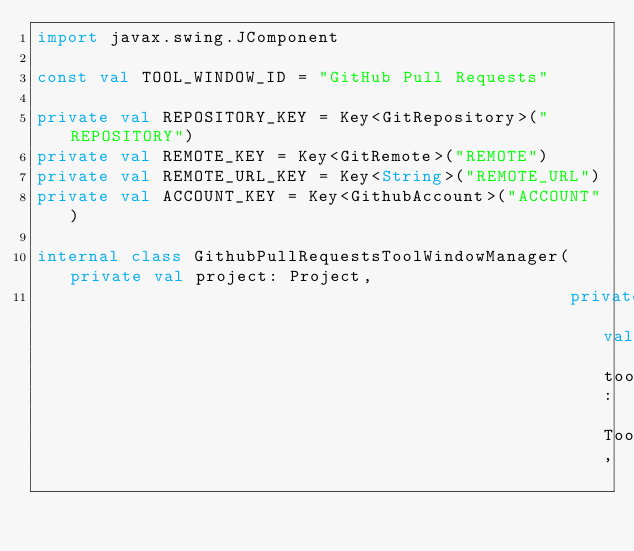<code> <loc_0><loc_0><loc_500><loc_500><_Kotlin_>import javax.swing.JComponent

const val TOOL_WINDOW_ID = "GitHub Pull Requests"

private val REPOSITORY_KEY = Key<GitRepository>("REPOSITORY")
private val REMOTE_KEY = Key<GitRemote>("REMOTE")
private val REMOTE_URL_KEY = Key<String>("REMOTE_URL")
private val ACCOUNT_KEY = Key<GithubAccount>("ACCOUNT")

internal class GithubPullRequestsToolWindowManager(private val project: Project,
                                                   private val toolWindowManager: ToolWindowManager,</code> 